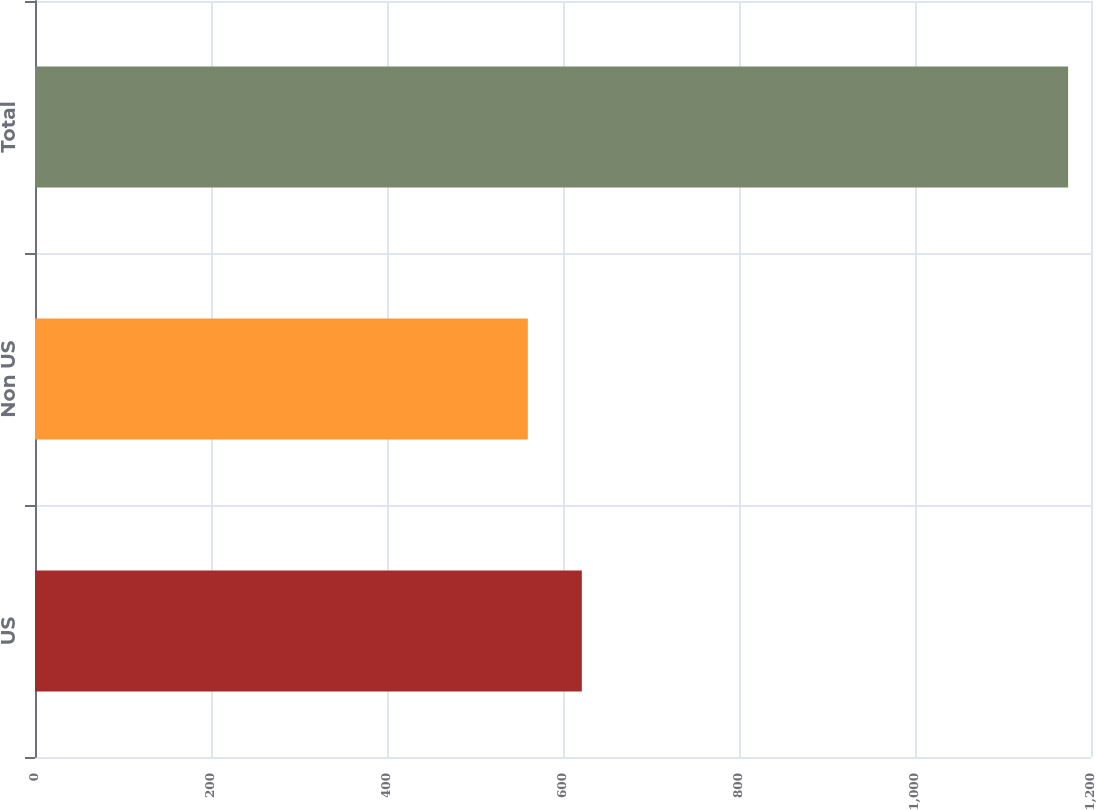Convert chart. <chart><loc_0><loc_0><loc_500><loc_500><bar_chart><fcel>US<fcel>Non US<fcel>Total<nl><fcel>621.4<fcel>560<fcel>1174<nl></chart> 